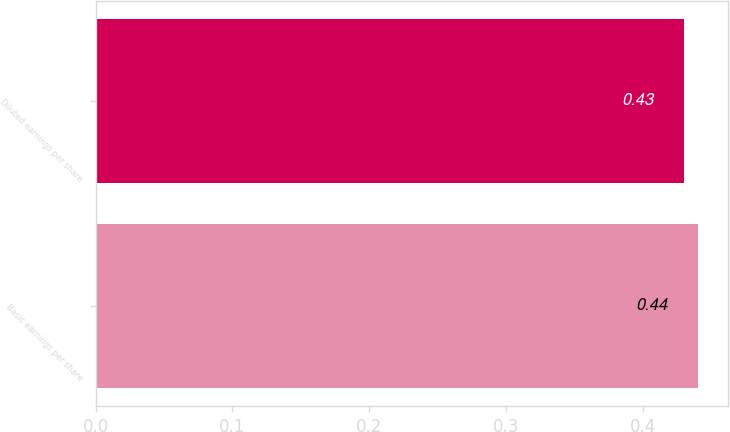Convert chart. <chart><loc_0><loc_0><loc_500><loc_500><bar_chart><fcel>Basic earnings per share<fcel>Diluted earnings per share<nl><fcel>0.44<fcel>0.43<nl></chart> 